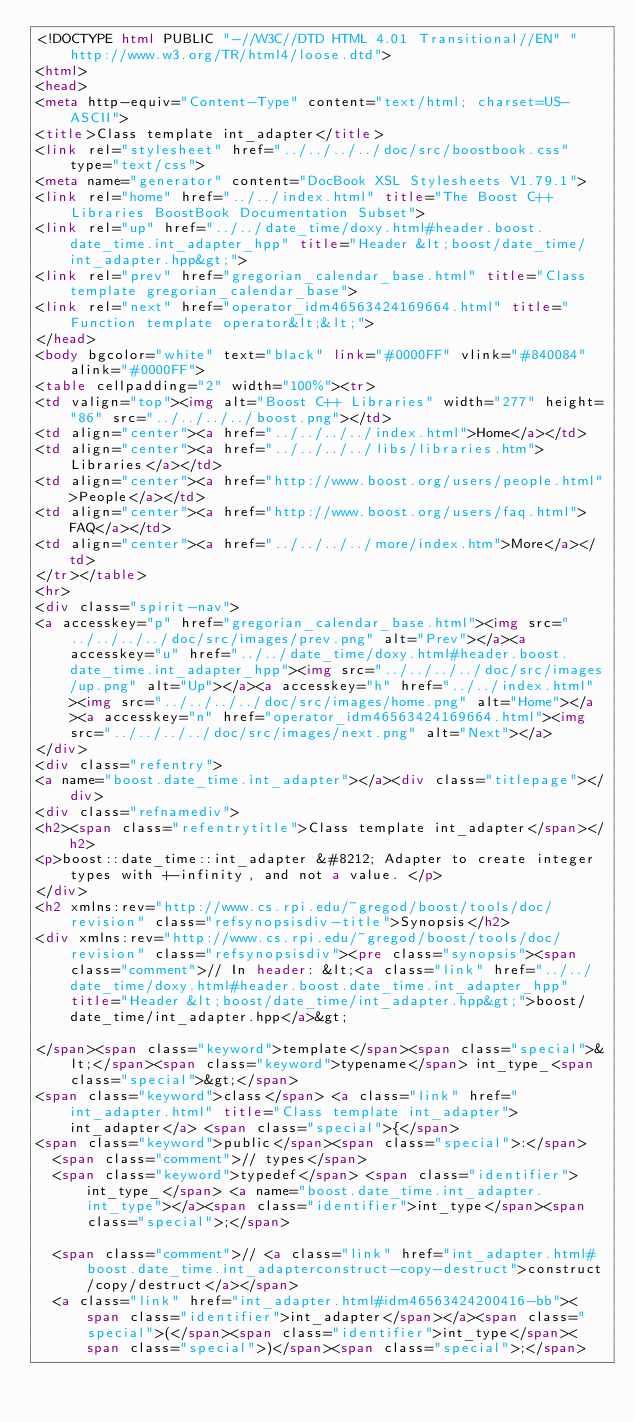Convert code to text. <code><loc_0><loc_0><loc_500><loc_500><_HTML_><!DOCTYPE html PUBLIC "-//W3C//DTD HTML 4.01 Transitional//EN" "http://www.w3.org/TR/html4/loose.dtd">
<html>
<head>
<meta http-equiv="Content-Type" content="text/html; charset=US-ASCII">
<title>Class template int_adapter</title>
<link rel="stylesheet" href="../../../../doc/src/boostbook.css" type="text/css">
<meta name="generator" content="DocBook XSL Stylesheets V1.79.1">
<link rel="home" href="../../index.html" title="The Boost C++ Libraries BoostBook Documentation Subset">
<link rel="up" href="../../date_time/doxy.html#header.boost.date_time.int_adapter_hpp" title="Header &lt;boost/date_time/int_adapter.hpp&gt;">
<link rel="prev" href="gregorian_calendar_base.html" title="Class template gregorian_calendar_base">
<link rel="next" href="operator_idm46563424169664.html" title="Function template operator&lt;&lt;">
</head>
<body bgcolor="white" text="black" link="#0000FF" vlink="#840084" alink="#0000FF">
<table cellpadding="2" width="100%"><tr>
<td valign="top"><img alt="Boost C++ Libraries" width="277" height="86" src="../../../../boost.png"></td>
<td align="center"><a href="../../../../index.html">Home</a></td>
<td align="center"><a href="../../../../libs/libraries.htm">Libraries</a></td>
<td align="center"><a href="http://www.boost.org/users/people.html">People</a></td>
<td align="center"><a href="http://www.boost.org/users/faq.html">FAQ</a></td>
<td align="center"><a href="../../../../more/index.htm">More</a></td>
</tr></table>
<hr>
<div class="spirit-nav">
<a accesskey="p" href="gregorian_calendar_base.html"><img src="../../../../doc/src/images/prev.png" alt="Prev"></a><a accesskey="u" href="../../date_time/doxy.html#header.boost.date_time.int_adapter_hpp"><img src="../../../../doc/src/images/up.png" alt="Up"></a><a accesskey="h" href="../../index.html"><img src="../../../../doc/src/images/home.png" alt="Home"></a><a accesskey="n" href="operator_idm46563424169664.html"><img src="../../../../doc/src/images/next.png" alt="Next"></a>
</div>
<div class="refentry">
<a name="boost.date_time.int_adapter"></a><div class="titlepage"></div>
<div class="refnamediv">
<h2><span class="refentrytitle">Class template int_adapter</span></h2>
<p>boost::date_time::int_adapter &#8212; Adapter to create integer types with +-infinity, and not a value. </p>
</div>
<h2 xmlns:rev="http://www.cs.rpi.edu/~gregod/boost/tools/doc/revision" class="refsynopsisdiv-title">Synopsis</h2>
<div xmlns:rev="http://www.cs.rpi.edu/~gregod/boost/tools/doc/revision" class="refsynopsisdiv"><pre class="synopsis"><span class="comment">// In header: &lt;<a class="link" href="../../date_time/doxy.html#header.boost.date_time.int_adapter_hpp" title="Header &lt;boost/date_time/int_adapter.hpp&gt;">boost/date_time/int_adapter.hpp</a>&gt;

</span><span class="keyword">template</span><span class="special">&lt;</span><span class="keyword">typename</span> int_type_<span class="special">&gt;</span> 
<span class="keyword">class</span> <a class="link" href="int_adapter.html" title="Class template int_adapter">int_adapter</a> <span class="special">{</span>
<span class="keyword">public</span><span class="special">:</span>
  <span class="comment">// types</span>
  <span class="keyword">typedef</span> <span class="identifier">int_type_</span> <a name="boost.date_time.int_adapter.int_type"></a><span class="identifier">int_type</span><span class="special">;</span>

  <span class="comment">// <a class="link" href="int_adapter.html#boost.date_time.int_adapterconstruct-copy-destruct">construct/copy/destruct</a></span>
  <a class="link" href="int_adapter.html#idm46563424200416-bb"><span class="identifier">int_adapter</span></a><span class="special">(</span><span class="identifier">int_type</span><span class="special">)</span><span class="special">;</span>
</code> 